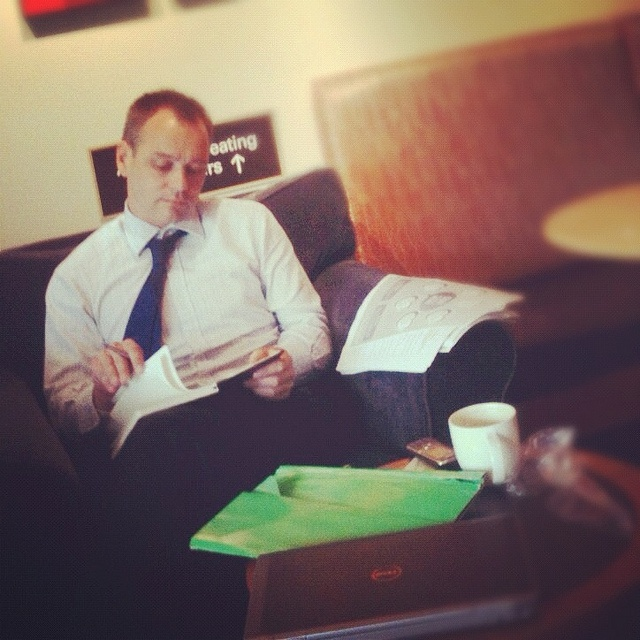Describe the objects in this image and their specific colors. I can see people in tan, black, beige, and darkgray tones, couch in tan, brown, maroon, and black tones, couch in tan, black, and purple tones, laptop in tan, black, purple, and gray tones, and cup in tan, beige, darkgray, lightgray, and gray tones in this image. 